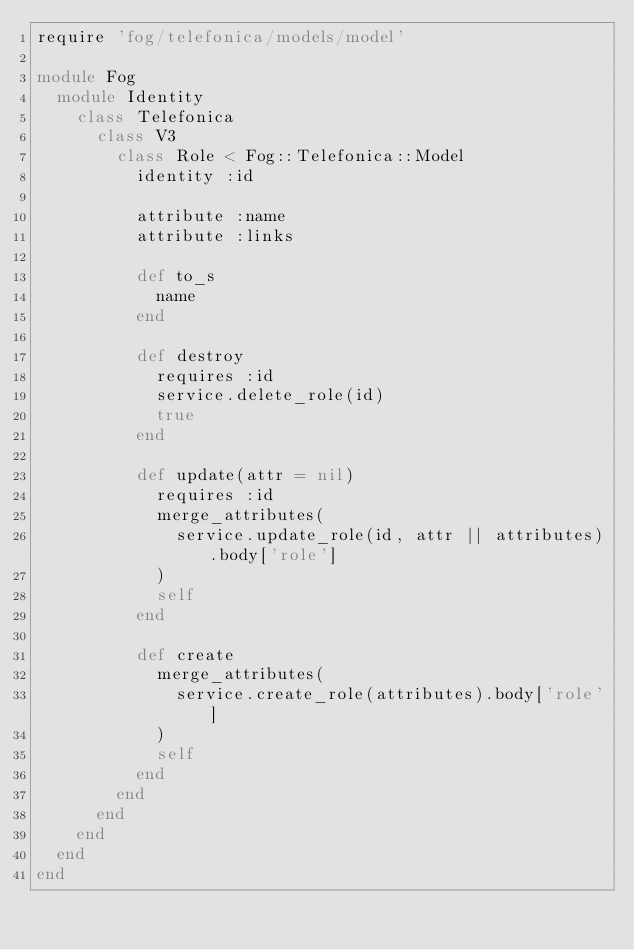<code> <loc_0><loc_0><loc_500><loc_500><_Ruby_>require 'fog/telefonica/models/model'

module Fog
  module Identity
    class Telefonica
      class V3
        class Role < Fog::Telefonica::Model
          identity :id

          attribute :name
          attribute :links

          def to_s
            name
          end

          def destroy
            requires :id
            service.delete_role(id)
            true
          end

          def update(attr = nil)
            requires :id
            merge_attributes(
              service.update_role(id, attr || attributes).body['role']
            )
            self
          end

          def create
            merge_attributes(
              service.create_role(attributes).body['role']
            )
            self
          end
        end
      end
    end
  end
end
</code> 